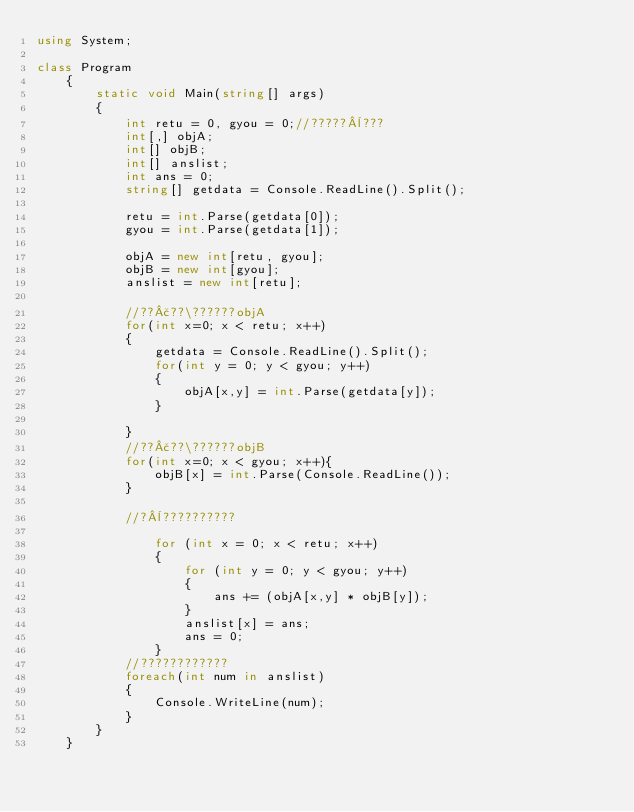<code> <loc_0><loc_0><loc_500><loc_500><_C#_>using System;

class Program
    {
        static void Main(string[] args)
        {
            int retu = 0, gyou = 0;//?????¨???
            int[,] objA;
            int[] objB;
            int[] anslist;
            int ans = 0;
            string[] getdata = Console.ReadLine().Split();

            retu = int.Parse(getdata[0]);
            gyou = int.Parse(getdata[1]);

            objA = new int[retu, gyou];
            objB = new int[gyou];
            anslist = new int[retu];

            //??£??\??????objA
            for(int x=0; x < retu; x++)
            {
                getdata = Console.ReadLine().Split();
                for(int y = 0; y < gyou; y++)
                {
                    objA[x,y] = int.Parse(getdata[y]);
                }

            }
            //??£??\??????objB
            for(int x=0; x < gyou; x++){
                objB[x] = int.Parse(Console.ReadLine());
            }

            //?¨??????????

                for (int x = 0; x < retu; x++)
                {
                    for (int y = 0; y < gyou; y++)
                    {
                        ans += (objA[x,y] * objB[y]);
                    }
                    anslist[x] = ans;
                    ans = 0;
                }
            //????????????
            foreach(int num in anslist)
            {
                Console.WriteLine(num);
            }
        }
    }</code> 